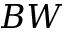<formula> <loc_0><loc_0><loc_500><loc_500>B W</formula> 